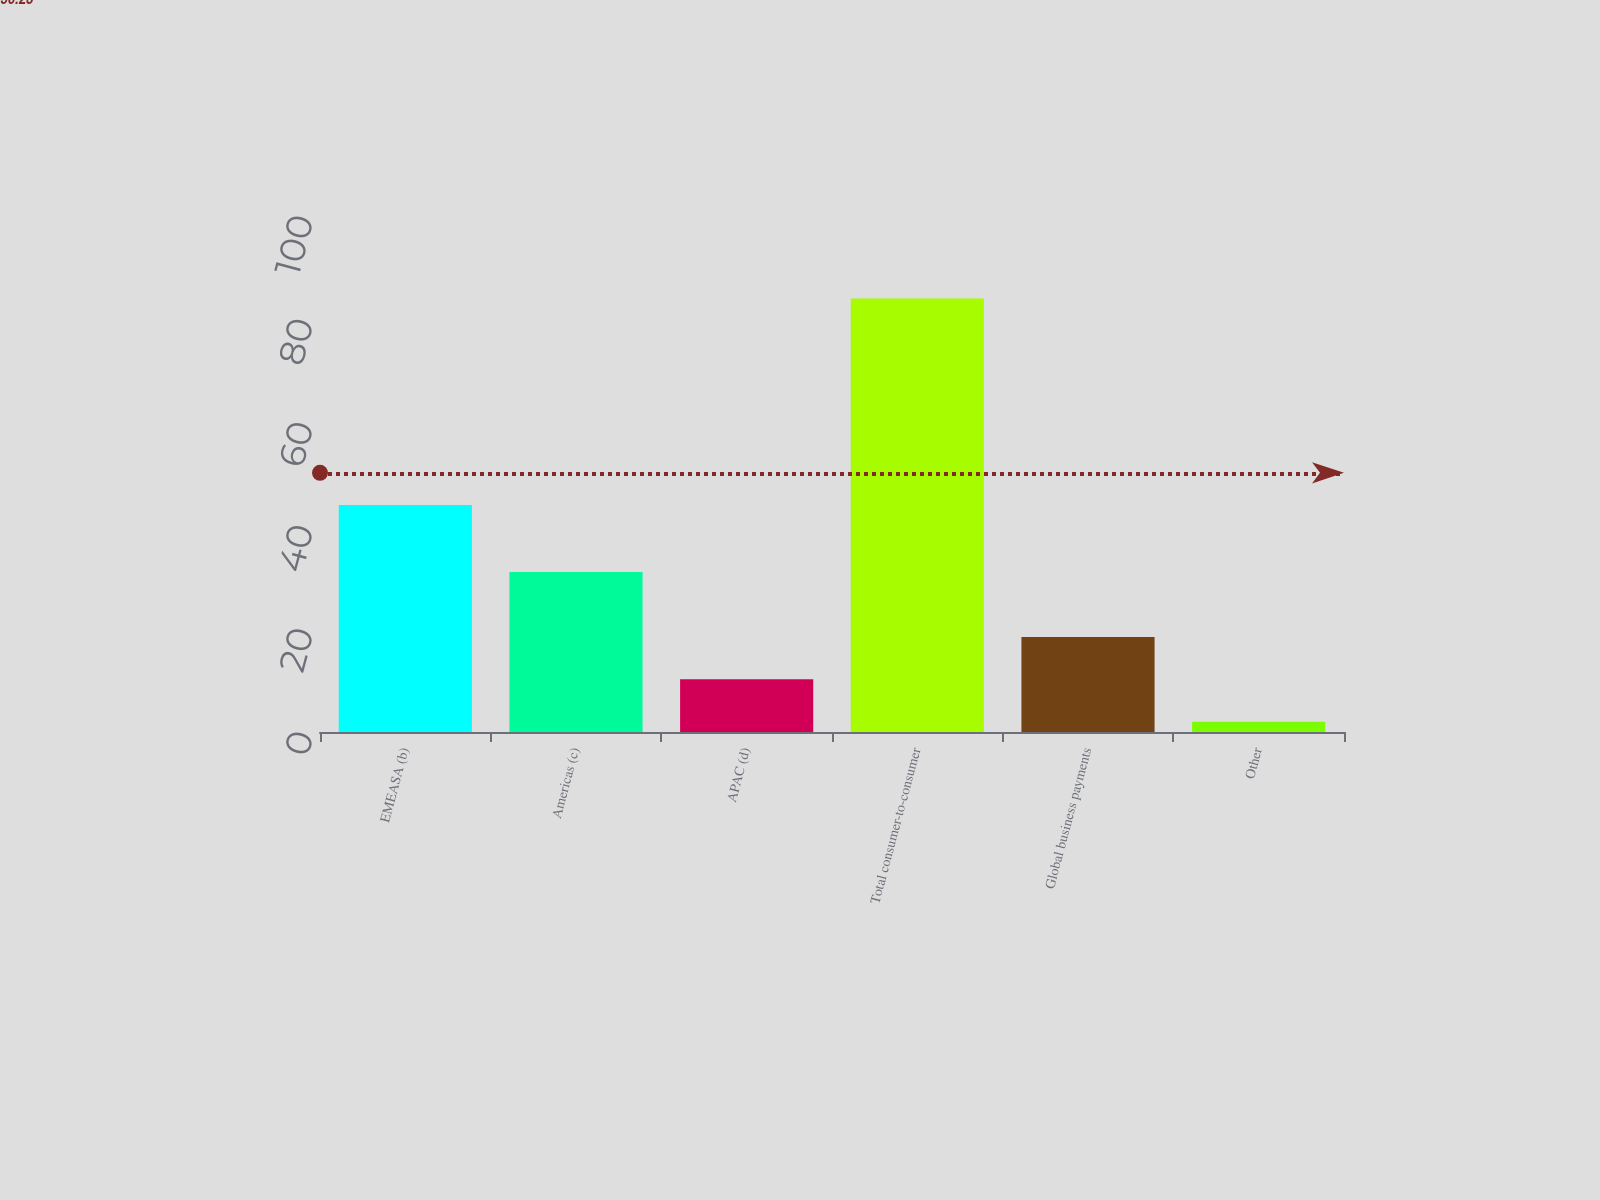Convert chart. <chart><loc_0><loc_0><loc_500><loc_500><bar_chart><fcel>EMEASA (b)<fcel>Americas (c)<fcel>APAC (d)<fcel>Total consumer-to-consumer<fcel>Global business payments<fcel>Other<nl><fcel>44<fcel>31<fcel>10.2<fcel>84<fcel>18.4<fcel>2<nl></chart> 